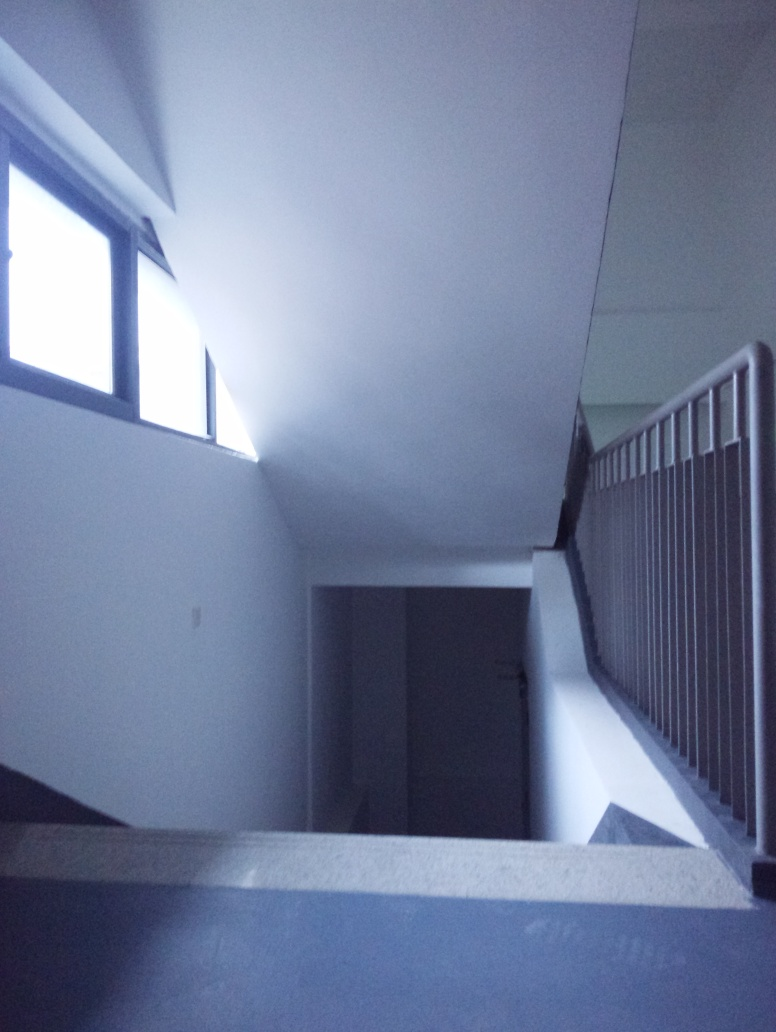Is this a place you would find comfortable to be in, and why? Comfort is subjective, but this place might feel comfortable to those who appreciate solitude and quiet spaces. Its spare, uncluttered appearance could be soothing. However, others might find it too stark or isolating due to the lack of decorative elements and perceived warmth. 